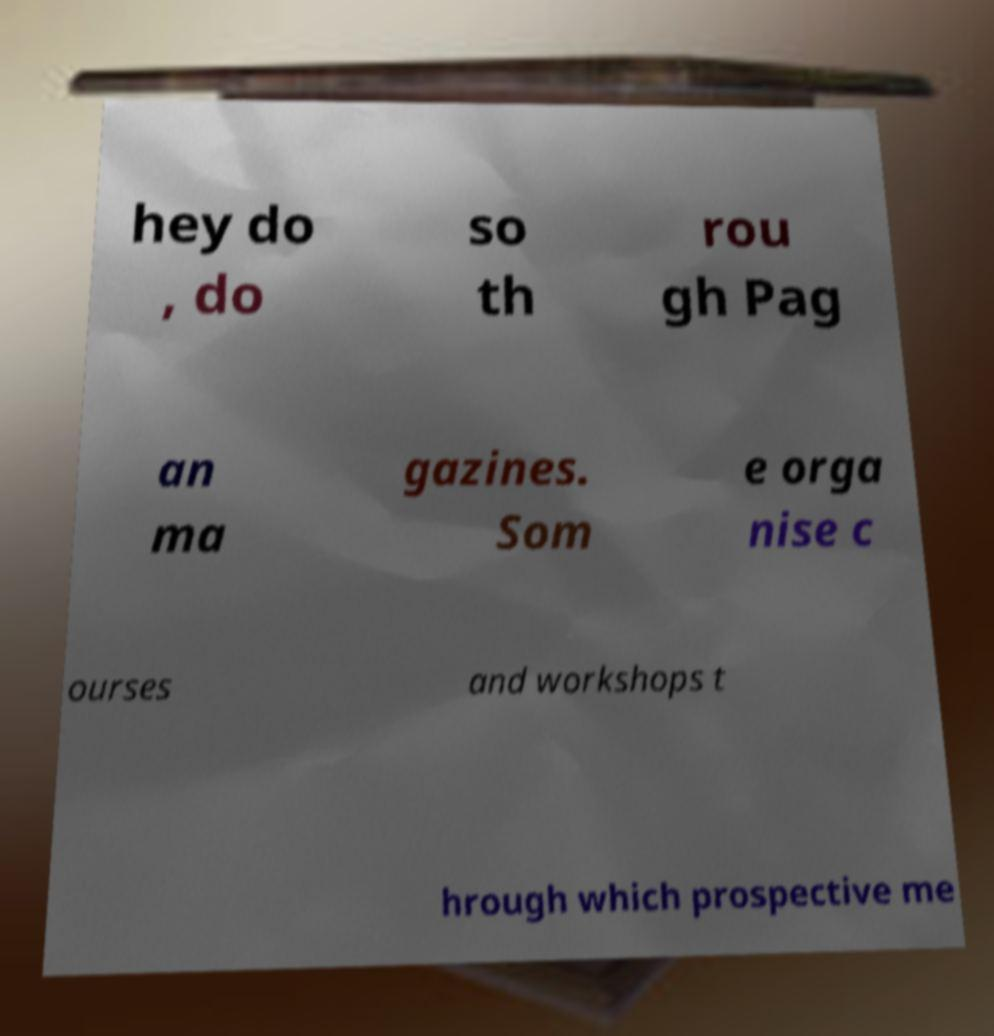For documentation purposes, I need the text within this image transcribed. Could you provide that? hey do , do so th rou gh Pag an ma gazines. Som e orga nise c ourses and workshops t hrough which prospective me 